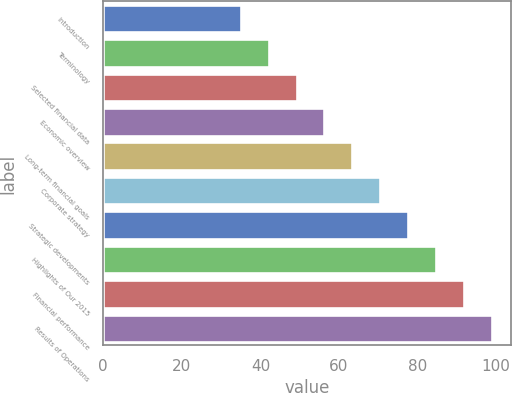<chart> <loc_0><loc_0><loc_500><loc_500><bar_chart><fcel>Introduction<fcel>Terminology<fcel>Selected financial data<fcel>Economic overview<fcel>Long-term financial goals<fcel>Corporate strategy<fcel>Strategic developments<fcel>Highlights of Our 2015<fcel>Financial performance<fcel>Results of Operations<nl><fcel>35<fcel>42.1<fcel>49.2<fcel>56.3<fcel>63.4<fcel>70.5<fcel>77.6<fcel>84.7<fcel>91.8<fcel>98.9<nl></chart> 